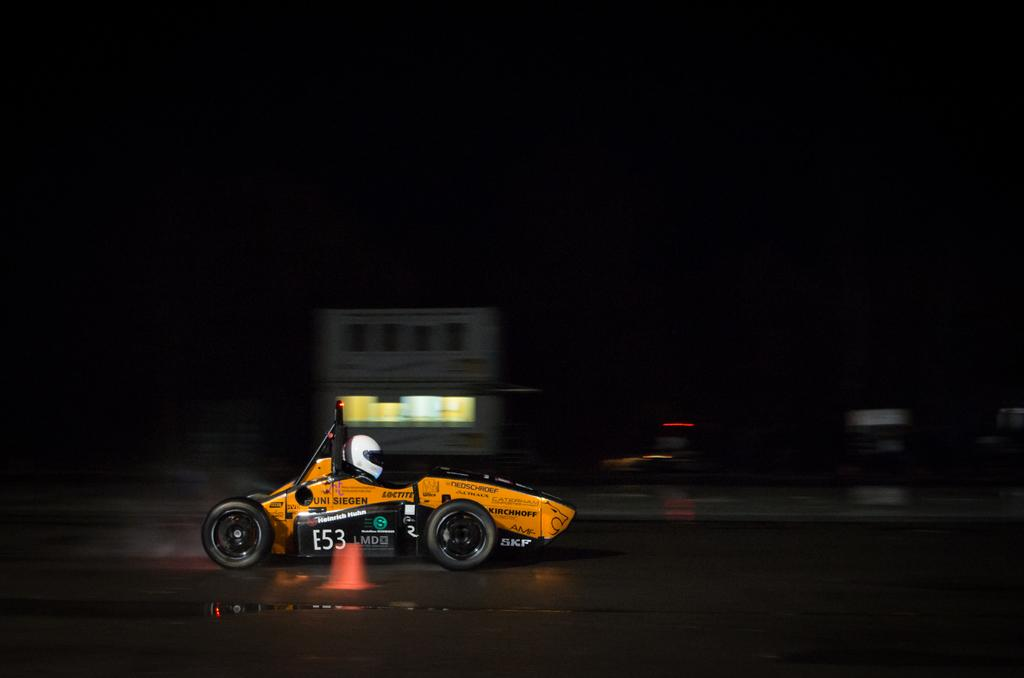What is the overall lighting condition of the image? The image is dark. What is the person in the image doing? The person is sitting in a vehicle. What protective gear is the person wearing? The person is wearing a helmet. What object can be seen on the road in the image? There is a traffic cone on the road. How would you describe the background of the image? The background of the image is blurry. What type of soap is being used to clean the harbor in the image? There is no harbor or soap present in the image. What historical event is being commemorated in the image? There is no indication of a historical event being commemorated in the image. 